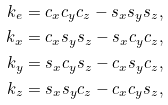<formula> <loc_0><loc_0><loc_500><loc_500>k _ { e } = c _ { x } c _ { y } c _ { z } - s _ { x } s _ { y } s _ { z } , \\ k _ { x } = c _ { x } s _ { y } s _ { z } - s _ { x } c _ { y } c _ { z } , \\ k _ { y } = s _ { x } c _ { y } s _ { z } - c _ { x } s _ { y } c _ { z } , \\ k _ { z } = s _ { x } s _ { y } c _ { z } - c _ { x } c _ { y } s _ { z } ,</formula> 